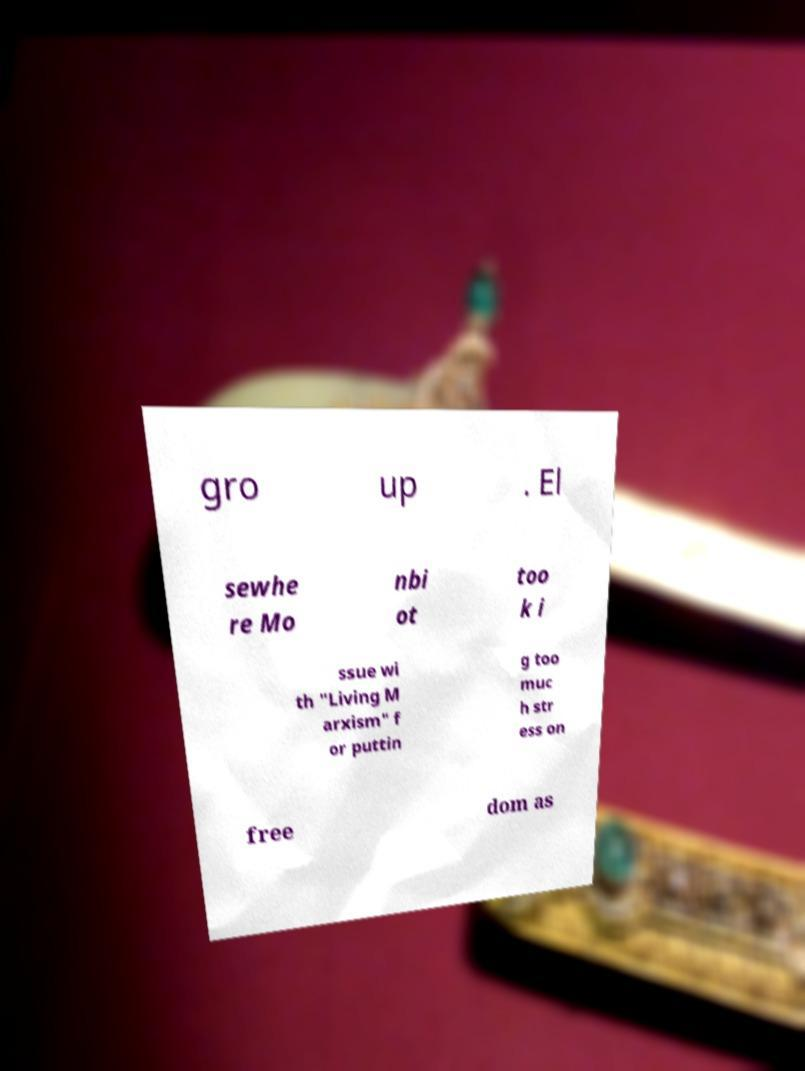Please read and relay the text visible in this image. What does it say? gro up . El sewhe re Mo nbi ot too k i ssue wi th "Living M arxism" f or puttin g too muc h str ess on free dom as 